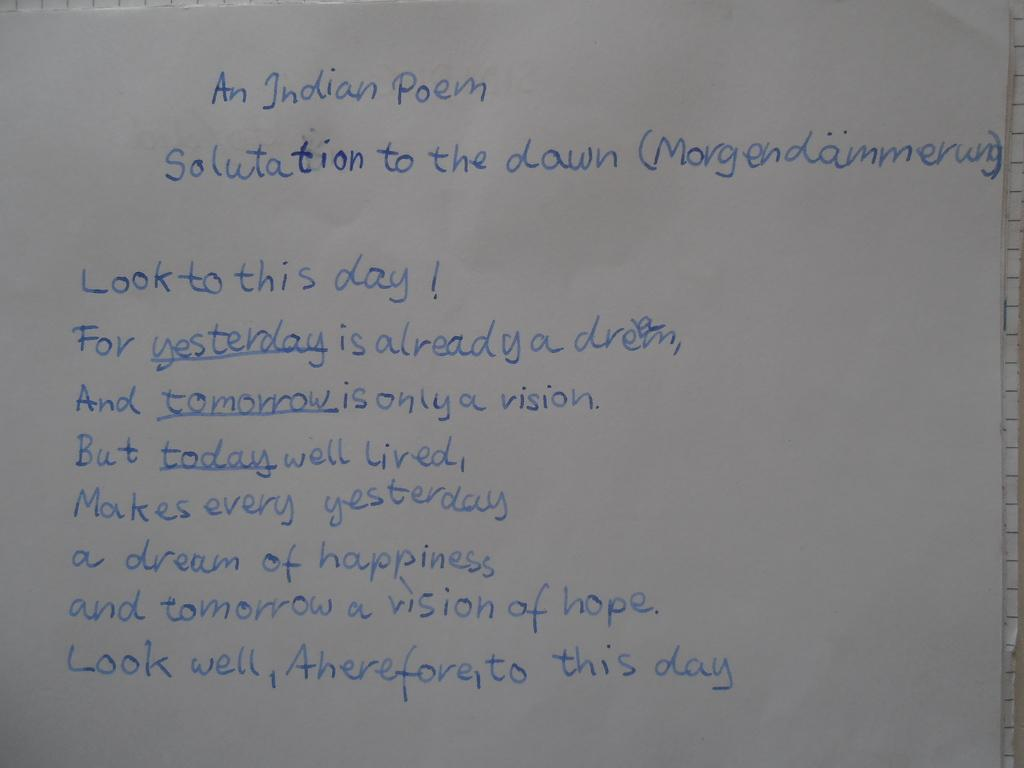What is present on the paper in the image? There is text on a paper in the image. What type of army is depicted in the veins of the text on the paper? There is no army or veins present in the image; it only features text on a paper. 